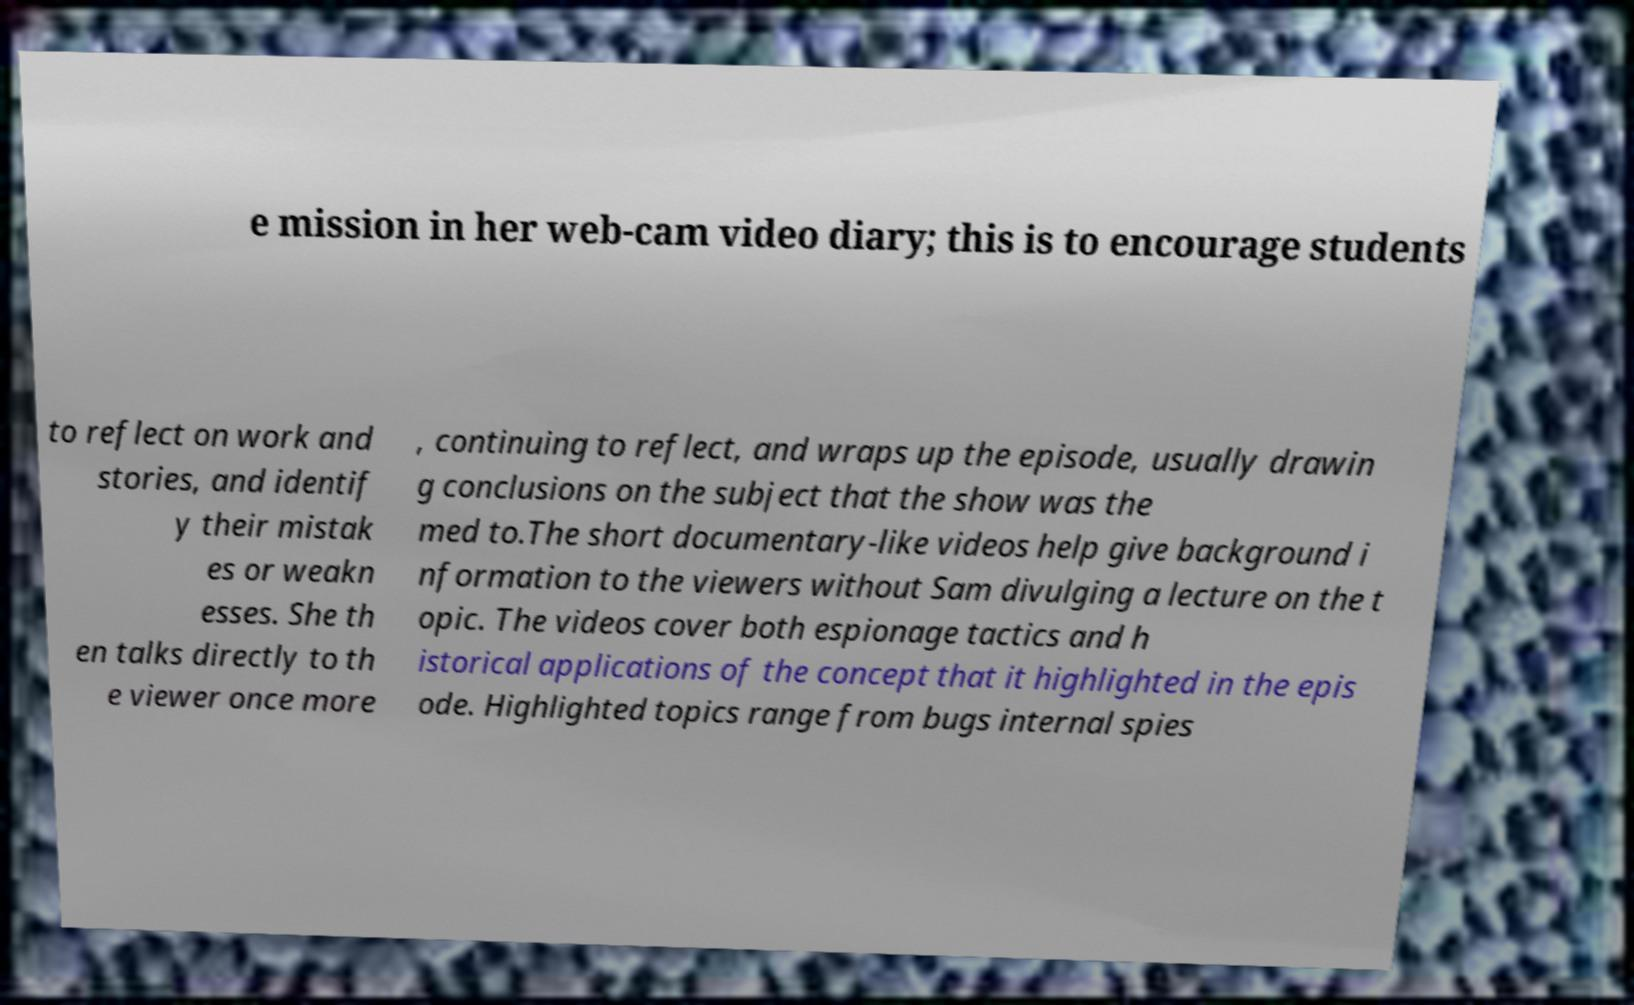What messages or text are displayed in this image? I need them in a readable, typed format. e mission in her web-cam video diary; this is to encourage students to reflect on work and stories, and identif y their mistak es or weakn esses. She th en talks directly to th e viewer once more , continuing to reflect, and wraps up the episode, usually drawin g conclusions on the subject that the show was the med to.The short documentary-like videos help give background i nformation to the viewers without Sam divulging a lecture on the t opic. The videos cover both espionage tactics and h istorical applications of the concept that it highlighted in the epis ode. Highlighted topics range from bugs internal spies 